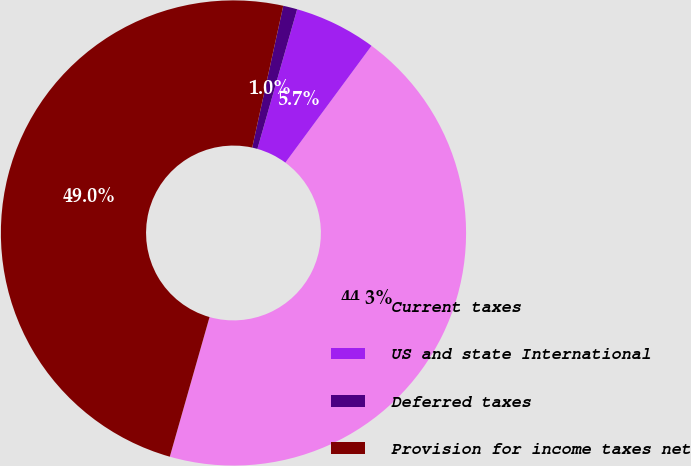Convert chart. <chart><loc_0><loc_0><loc_500><loc_500><pie_chart><fcel>Current taxes<fcel>US and state International<fcel>Deferred taxes<fcel>Provision for income taxes net<nl><fcel>44.3%<fcel>5.7%<fcel>0.98%<fcel>49.02%<nl></chart> 